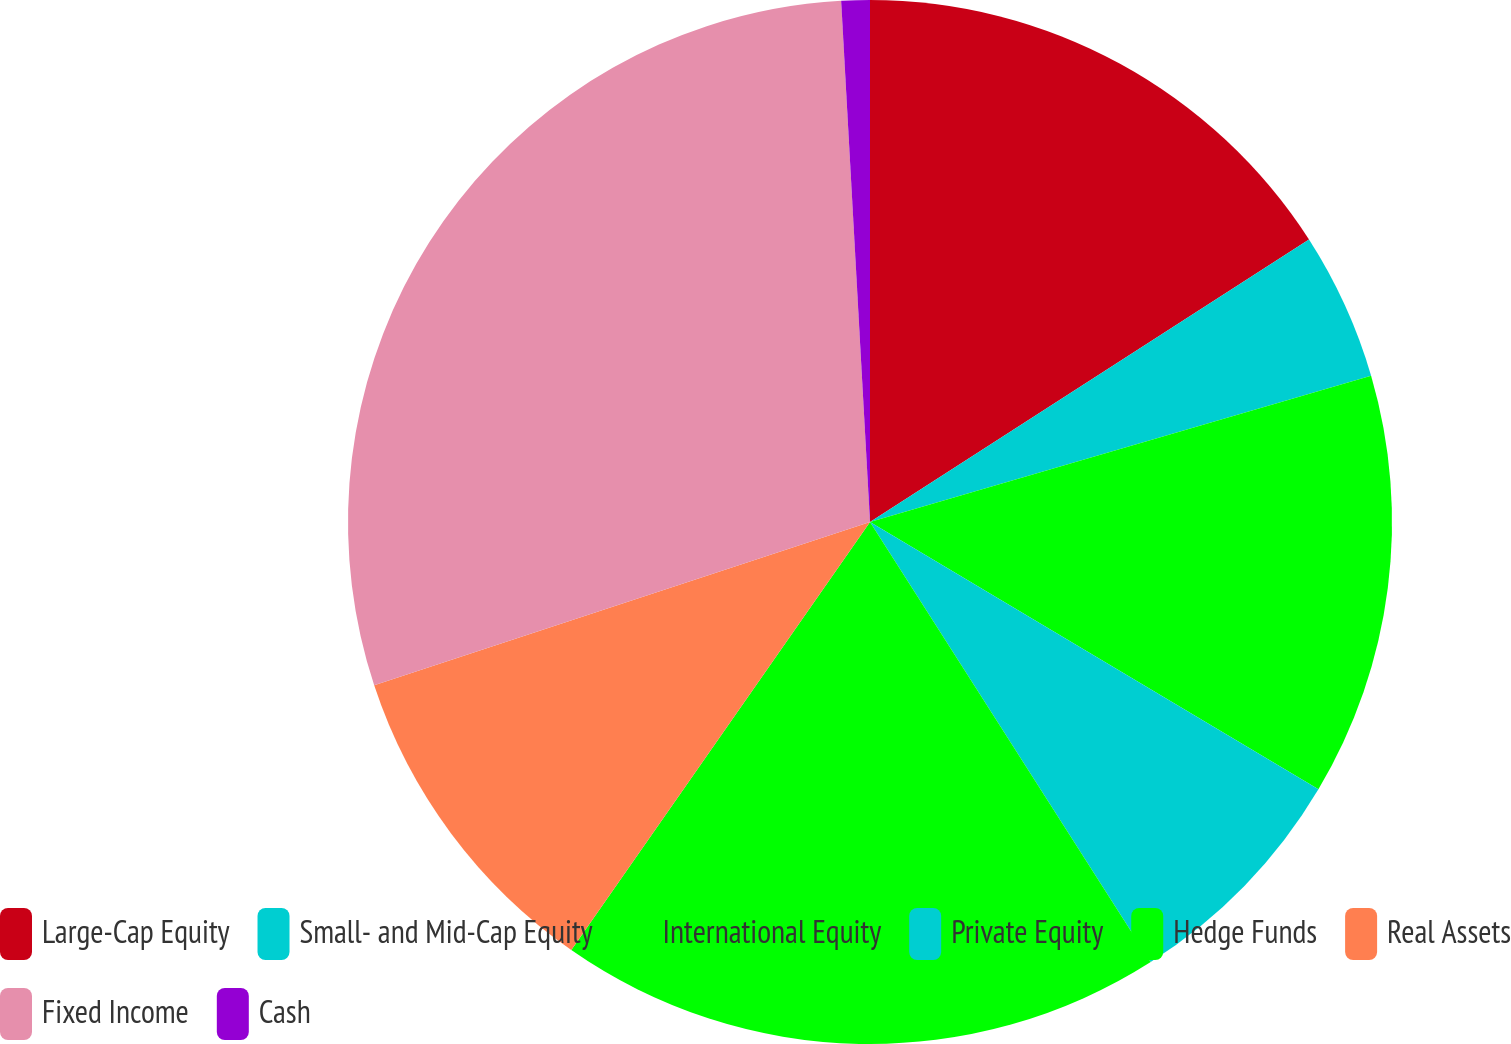<chart> <loc_0><loc_0><loc_500><loc_500><pie_chart><fcel>Large-Cap Equity<fcel>Small- and Mid-Cap Equity<fcel>International Equity<fcel>Private Equity<fcel>Hedge Funds<fcel>Real Assets<fcel>Fixed Income<fcel>Cash<nl><fcel>15.9%<fcel>4.58%<fcel>13.07%<fcel>7.41%<fcel>18.73%<fcel>10.24%<fcel>29.18%<fcel>0.88%<nl></chart> 